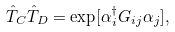Convert formula to latex. <formula><loc_0><loc_0><loc_500><loc_500>\hat { T } _ { C } \hat { T } _ { D } = \exp [ \alpha ^ { \dagger } _ { i } G _ { i j } \alpha _ { j } ] ,</formula> 